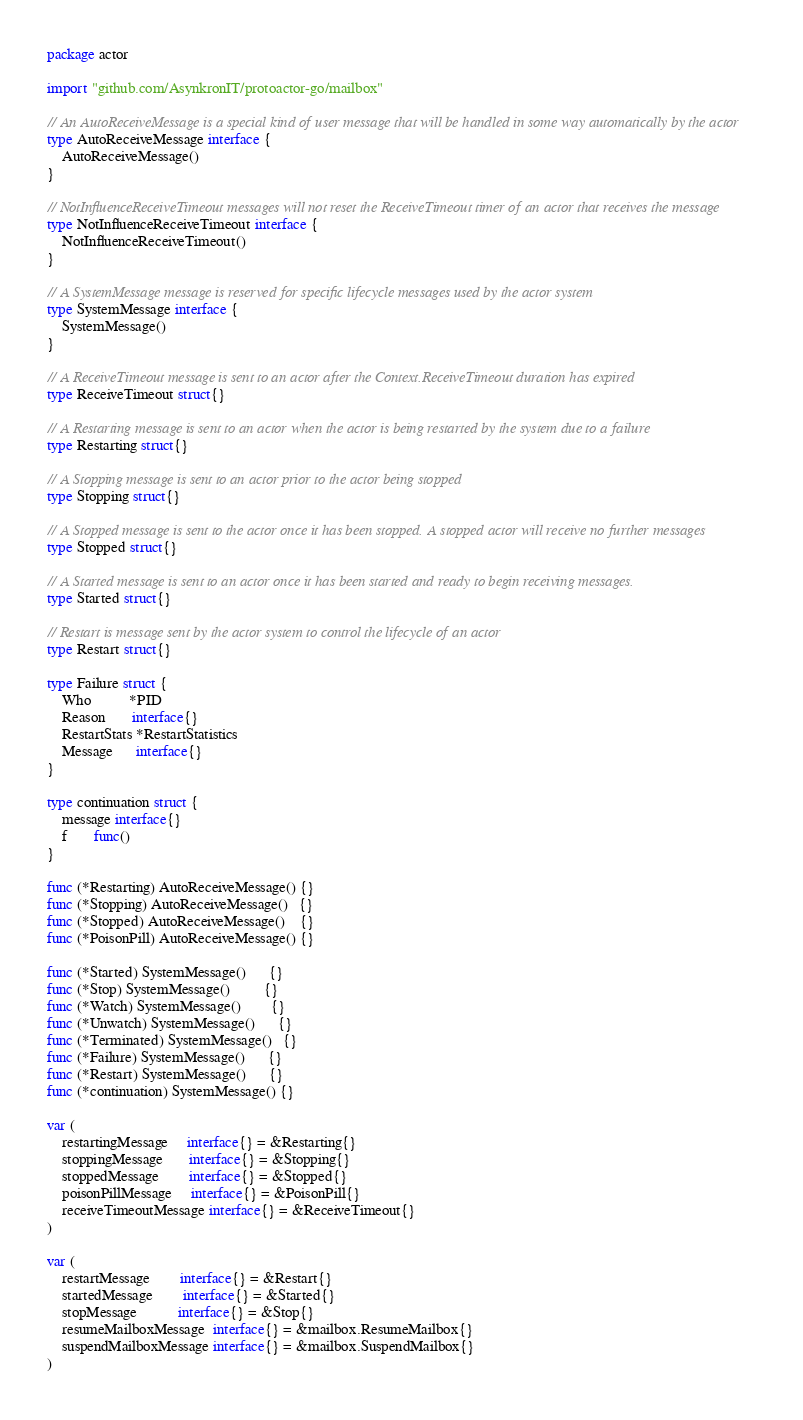Convert code to text. <code><loc_0><loc_0><loc_500><loc_500><_Go_>package actor

import "github.com/AsynkronIT/protoactor-go/mailbox"

// An AutoReceiveMessage is a special kind of user message that will be handled in some way automatically by the actor
type AutoReceiveMessage interface {
	AutoReceiveMessage()
}

// NotInfluenceReceiveTimeout messages will not reset the ReceiveTimeout timer of an actor that receives the message
type NotInfluenceReceiveTimeout interface {
	NotInfluenceReceiveTimeout()
}

// A SystemMessage message is reserved for specific lifecycle messages used by the actor system
type SystemMessage interface {
	SystemMessage()
}

// A ReceiveTimeout message is sent to an actor after the Context.ReceiveTimeout duration has expired
type ReceiveTimeout struct{}

// A Restarting message is sent to an actor when the actor is being restarted by the system due to a failure
type Restarting struct{}

// A Stopping message is sent to an actor prior to the actor being stopped
type Stopping struct{}

// A Stopped message is sent to the actor once it has been stopped. A stopped actor will receive no further messages
type Stopped struct{}

// A Started message is sent to an actor once it has been started and ready to begin receiving messages.
type Started struct{}

// Restart is message sent by the actor system to control the lifecycle of an actor
type Restart struct{}

type Failure struct {
	Who          *PID
	Reason       interface{}
	RestartStats *RestartStatistics
	Message      interface{}
}

type continuation struct {
	message interface{}
	f       func()
}

func (*Restarting) AutoReceiveMessage() {}
func (*Stopping) AutoReceiveMessage()   {}
func (*Stopped) AutoReceiveMessage()    {}
func (*PoisonPill) AutoReceiveMessage() {}

func (*Started) SystemMessage()      {}
func (*Stop) SystemMessage()         {}
func (*Watch) SystemMessage()        {}
func (*Unwatch) SystemMessage()      {}
func (*Terminated) SystemMessage()   {}
func (*Failure) SystemMessage()      {}
func (*Restart) SystemMessage()      {}
func (*continuation) SystemMessage() {}

var (
	restartingMessage     interface{} = &Restarting{}
	stoppingMessage       interface{} = &Stopping{}
	stoppedMessage        interface{} = &Stopped{}
	poisonPillMessage     interface{} = &PoisonPill{}
	receiveTimeoutMessage interface{} = &ReceiveTimeout{}
)

var (
	restartMessage        interface{} = &Restart{}
	startedMessage        interface{} = &Started{}
	stopMessage           interface{} = &Stop{}
	resumeMailboxMessage  interface{} = &mailbox.ResumeMailbox{}
	suspendMailboxMessage interface{} = &mailbox.SuspendMailbox{}
)
</code> 